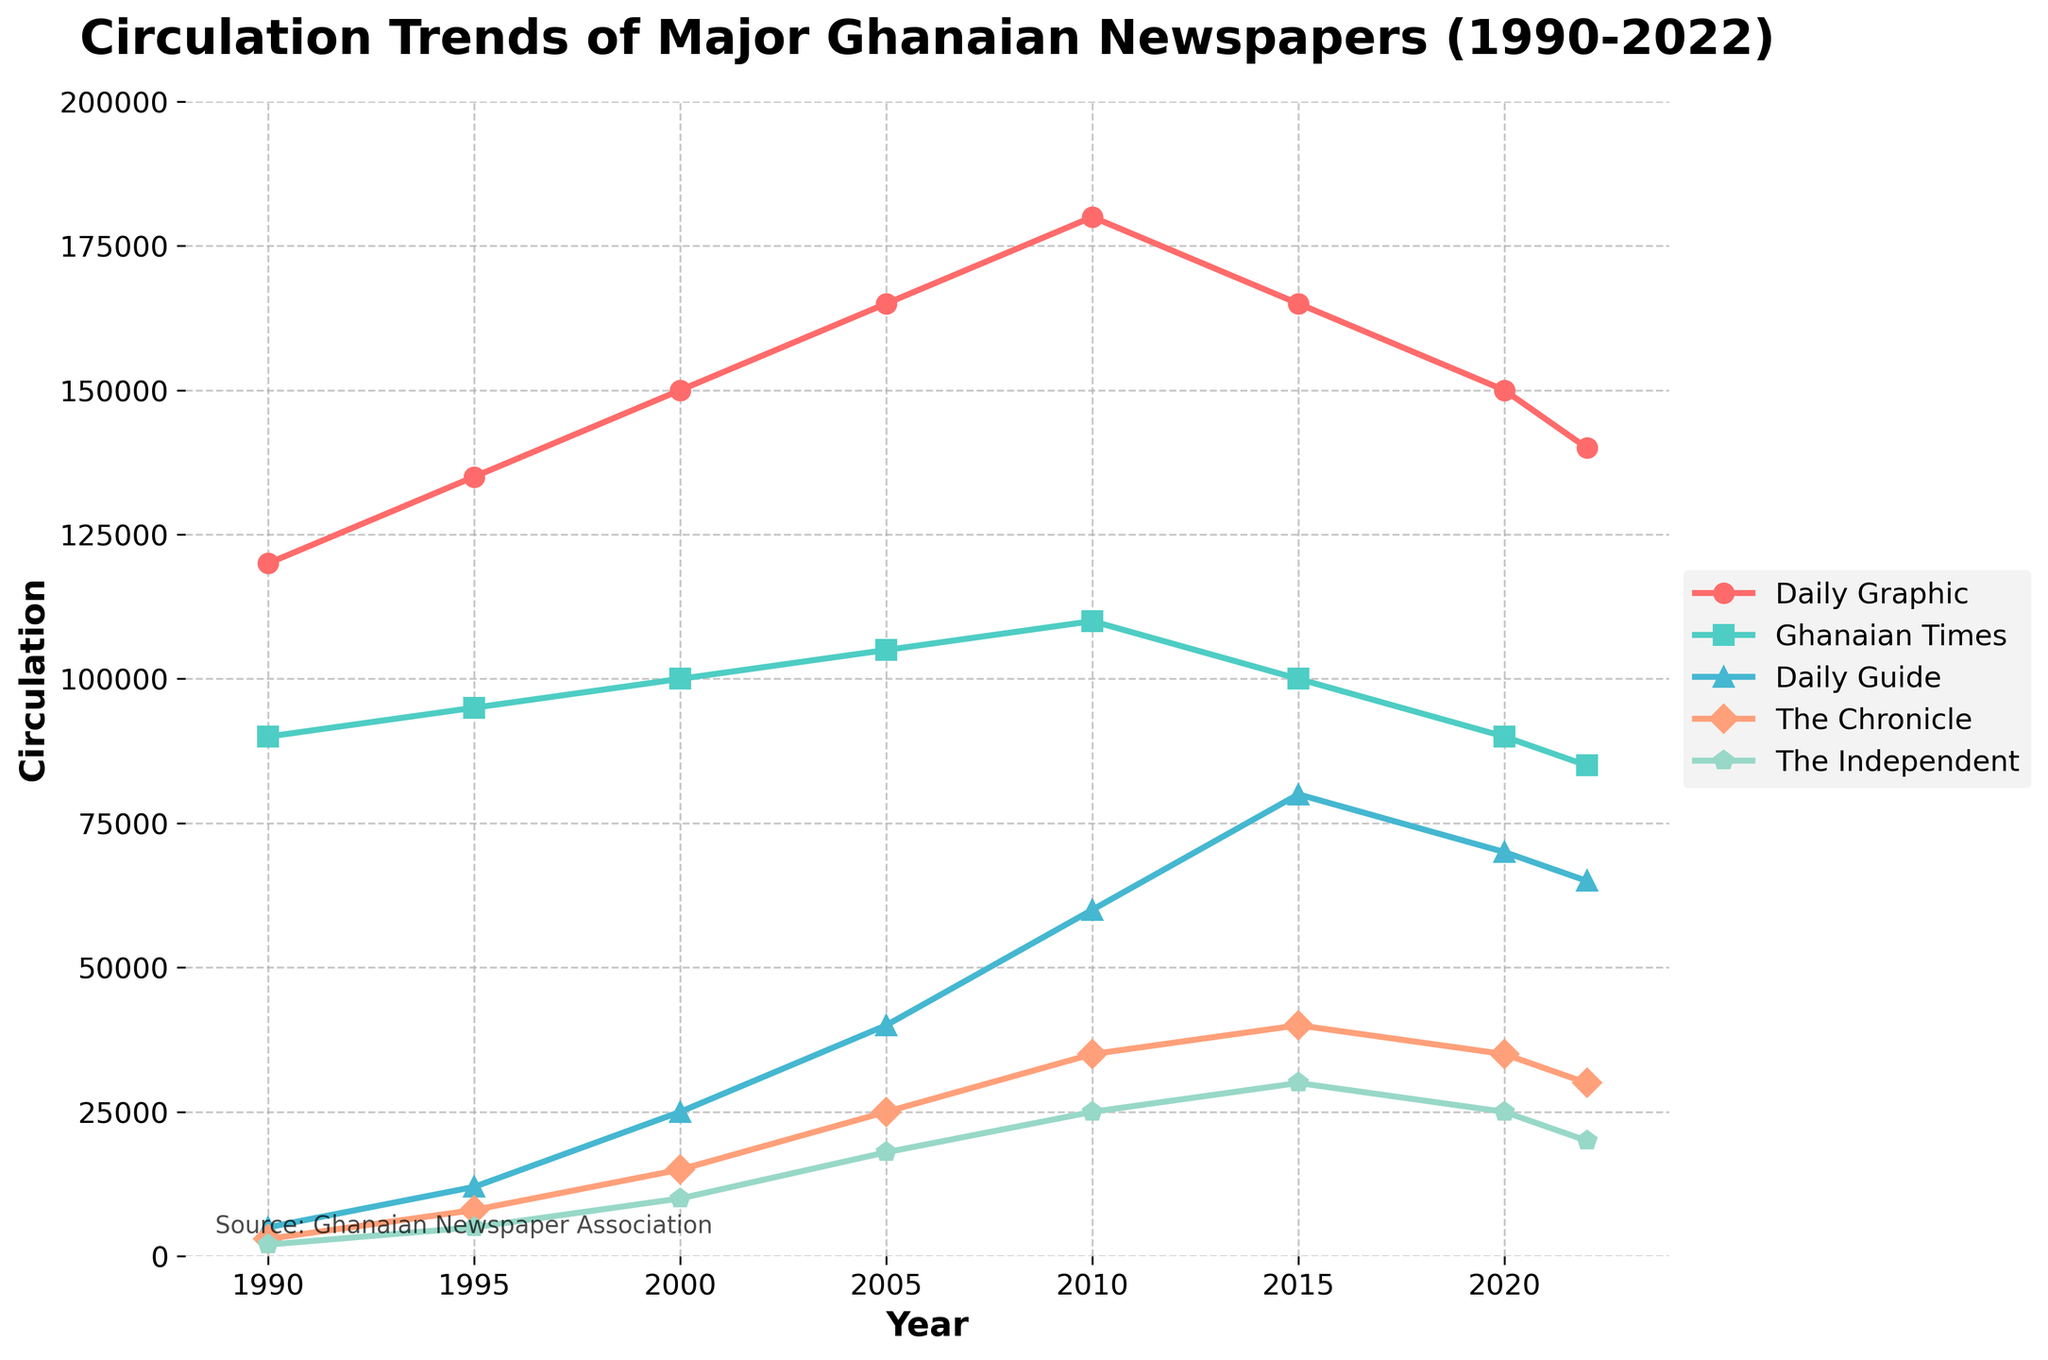what is the trend of the Daily Graphic’s circulation from 1990 to 2022? By observing the line representing the Daily Graphic's circulation, it can be seen that it generally increased from 1990 to 2010, peaking in 2010 at 180,000, before declining in 2015 to 165,000 and continuing to decrease until 2022 where it reached 140,000.
Answer: General upward trend until 2010, then a decline Which newspaper experienced the most significant growth in circulation between 1990 and 2015? Observing the trend lines, the Daily Guide shows the most substantial growth, starting from 5,000 in 1990 to 80,000 in 2015, indicating an increase of 75,000.
Answer: Daily Guide In which year did the Daily Graphic reach its highest circulation, and what was the circulation figure? From the chart, the Daily Graphic peaked in circulation in 2010 with a figure of 180,000.
Answer: 2010, 180,000 Compare the circulation of the Ghanaian Times in 1990 and 2022. How did it change? The Ghanaian Times had a circulation of 90,000 in 1990 and decreased to 85,000 in 2022, a reduction of 5,000.
Answer: Decreased by 5,000 What is the difference in circulation between the Daily Guide and The Chronicle in 2015? In 2015, the Daily Guide's circulation was 80,000, while The Chronicle's circulation was 40,000. The difference is 80,000 - 40,000 = 40,000.
Answer: 40,000 Which newspaper has the least circulation in 2022, and what is the figure? Looking at the year 2022, The Independent has the least circulation with a figure of 20,000.
Answer: The Independent, 20,000 How does the circulation of The Chronicle in 2000 compare to its circulation in 2022? In 2000, The Chronicle's circulation was 15,000, while in 2022 its circulation was 30,000. Comparing the two figures, The Chronicle's circulation doubled from 2000 to 2022.
Answer: Doubled What is the total circulation of all the newspapers in the year 2000? Summing the circulations in 2000: 150,000 (Daily Graphic) + 100,000 (Ghanaian Times) + 25,000 (Daily Guide) + 15,000 (The Chronicle) + 10,000 (The Independent) = 300,000.
Answer: 300,000 Identify the two newspapers with the most consistent trends from 1990 to 2022. By observing the lines, the Daily Graphic and Ghanaian Times show more consistent trends compared to the other newspapers, despite some fluctuations in numbers.
Answer: Daily Graphic and Ghanaian Times 